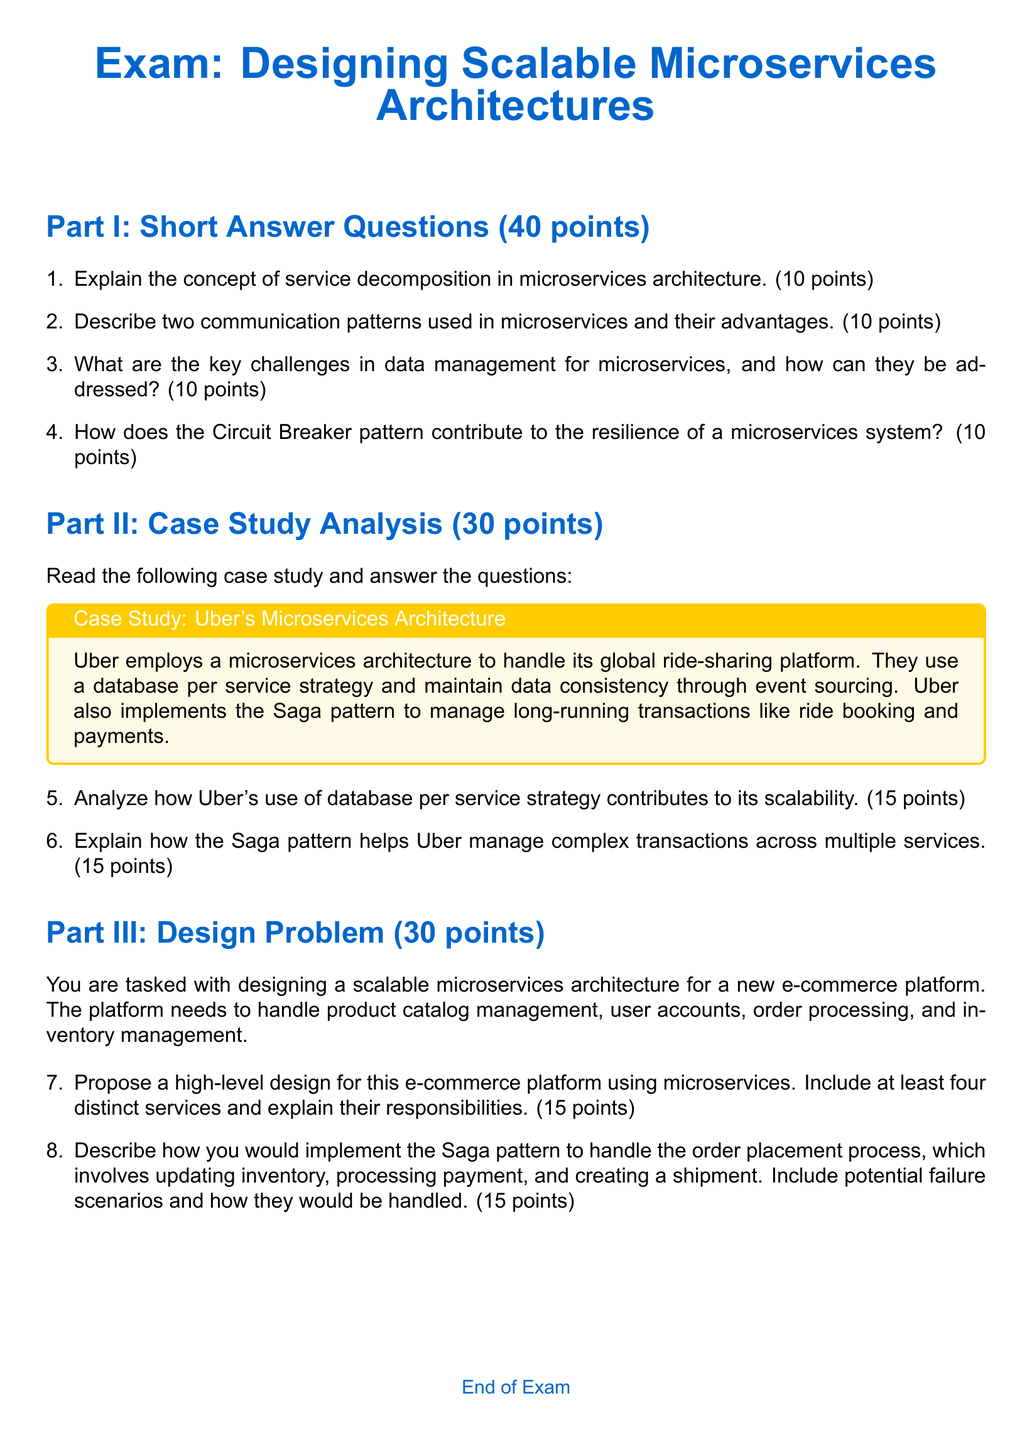What is the total points for Part I? Part I consists of four short answer questions, each worth 10 points, leading to a total of 40 points.
Answer: 40 points How many points is the Case Study Analysis section worth? The Case Study Analysis section is labeled as Part II and is worth 30 points.
Answer: 30 points What pattern does Uber implement to manage long-running transactions? The document states Uber uses the Saga pattern to manage long-running transactions like ride booking and payments.
Answer: Saga pattern In which part of the exam is service decomposition explained? Service decomposition is explained in Part I under the short answer questions section.
Answer: Part I How many distinct services should be included in the proposed design for the e-commerce platform? The design problem specifies that there should be at least four distinct services.
Answer: Four distinct services What type of data management strategy does Uber use? Uber employs a database per service strategy to manage its data.
Answer: Database per service What does the Circuit Breaker pattern contribute to? The Circuit Breaker pattern contributes to the resilience of a microservices system.
Answer: Resilience How many points is the Design Problem section worth? The Design Problem section is labeled as Part III and is worth 30 points.
Answer: 30 points What color is used for the main headings? The main headings utilize the color defined as "maincolor" which corresponds to RGB: 0,102,204.
Answer: RGB: 0,102,204 